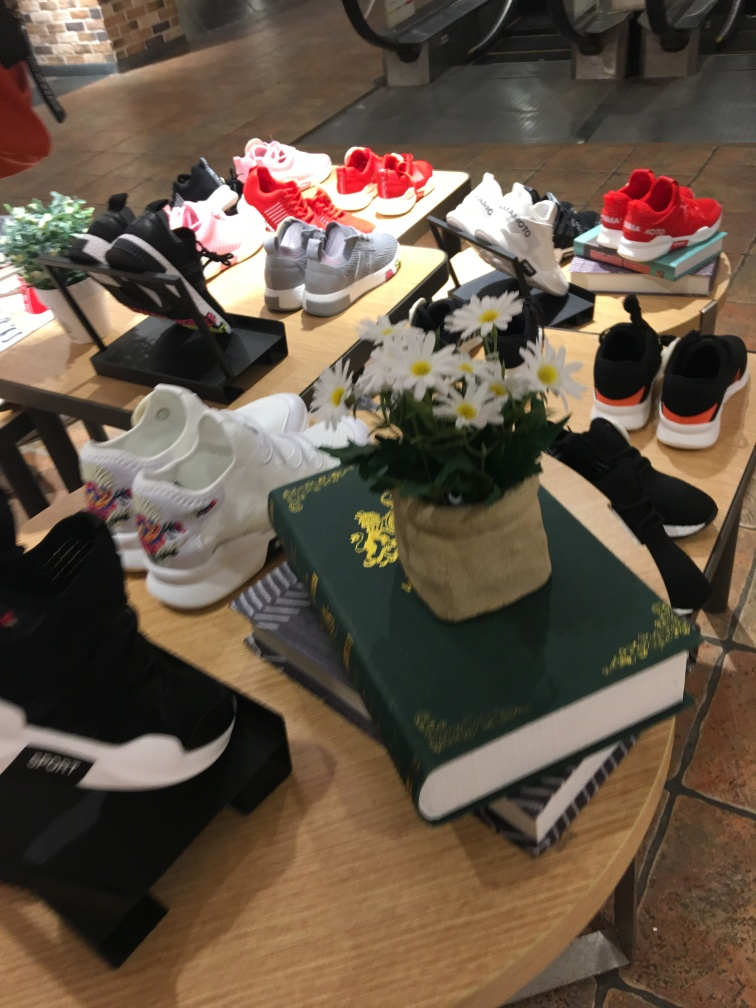Does the image retain texture details of the main subject? The image captures texture details of the various shoes on display, with sufficient clarity that one can observe the individual fabric weaves and stitch patterns. Surface qualities such as matte and glossy finishes are distinguishable. The flowers show less clarity, but overall, the textures are quite apparent, aligning with option A. 